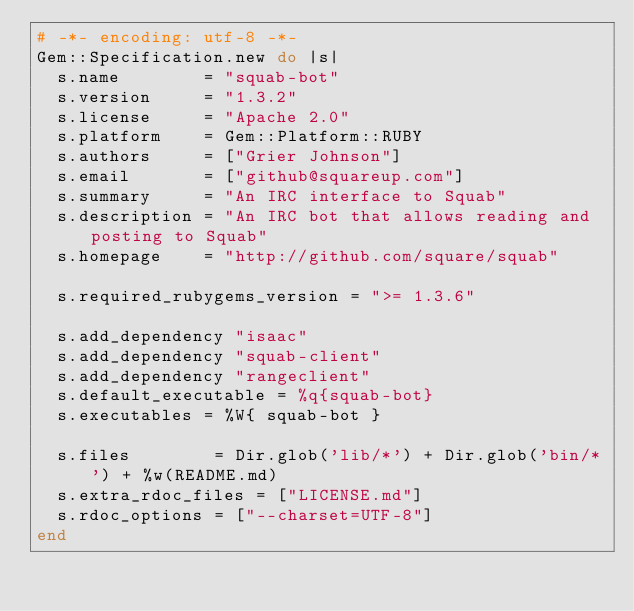<code> <loc_0><loc_0><loc_500><loc_500><_Ruby_># -*- encoding: utf-8 -*-
Gem::Specification.new do |s|
  s.name        = "squab-bot"
  s.version     = "1.3.2"
  s.license     = "Apache 2.0"
  s.platform    = Gem::Platform::RUBY
  s.authors     = ["Grier Johnson"]
  s.email       = ["github@squareup.com"]
  s.summary     = "An IRC interface to Squab"
  s.description = "An IRC bot that allows reading and posting to Squab"
  s.homepage    = "http://github.com/square/squab"

  s.required_rubygems_version = ">= 1.3.6"

  s.add_dependency "isaac"
  s.add_dependency "squab-client"
  s.add_dependency "rangeclient"
  s.default_executable = %q{squab-bot}
  s.executables = %W{ squab-bot }

  s.files        = Dir.glob('lib/*') + Dir.glob('bin/*') + %w(README.md)
  s.extra_rdoc_files = ["LICENSE.md"]
  s.rdoc_options = ["--charset=UTF-8"]
end

</code> 